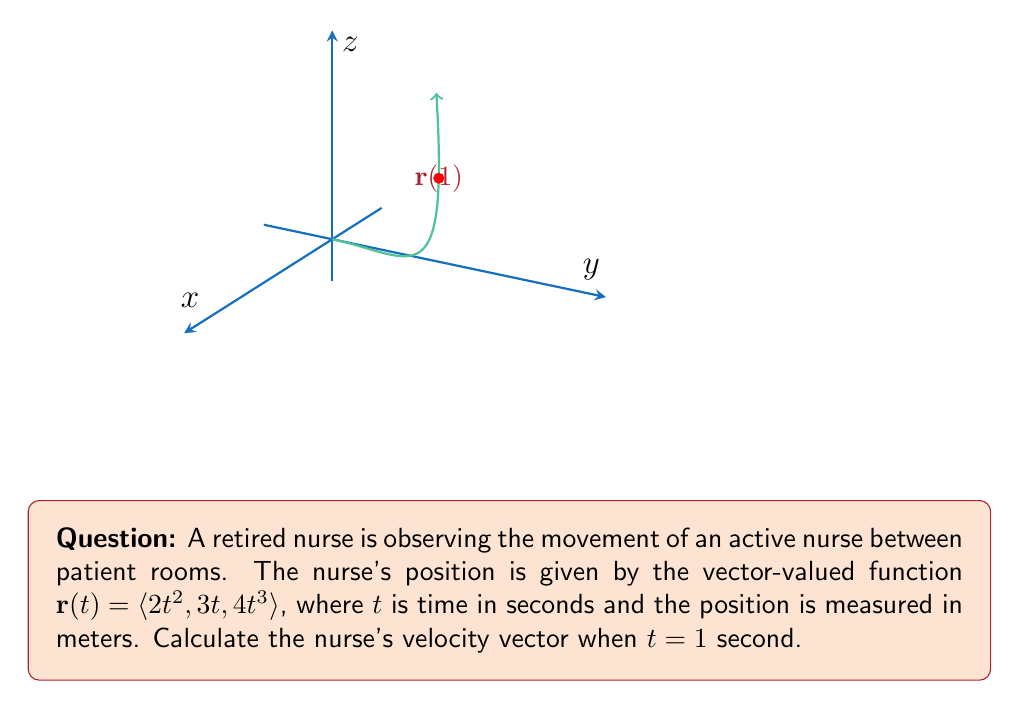Solve this math problem. To find the velocity vector, we need to differentiate the position vector $\mathbf{r}(t)$ with respect to time:

1) The velocity vector is given by $\mathbf{v}(t) = \frac{d\mathbf{r}}{dt}$

2) Let's differentiate each component of $\mathbf{r}(t)$:
   
   $\frac{d}{dt}(2t^2) = 4t$
   $\frac{d}{dt}(3t) = 3$
   $\frac{d}{dt}(4t^3) = 12t^2$

3) Therefore, the velocity vector function is:
   
   $\mathbf{v}(t) = \langle 4t, 3, 12t^2 \rangle$

4) To find the velocity at $t = 1$ second, we substitute $t = 1$ into $\mathbf{v}(t)$:
   
   $\mathbf{v}(1) = \langle 4(1), 3, 12(1)^2 \rangle = \langle 4, 3, 12 \rangle$

Thus, the nurse's velocity vector when $t = 1$ second is $\langle 4, 3, 12 \rangle$ meters per second.
Answer: $\langle 4, 3, 12 \rangle$ m/s 